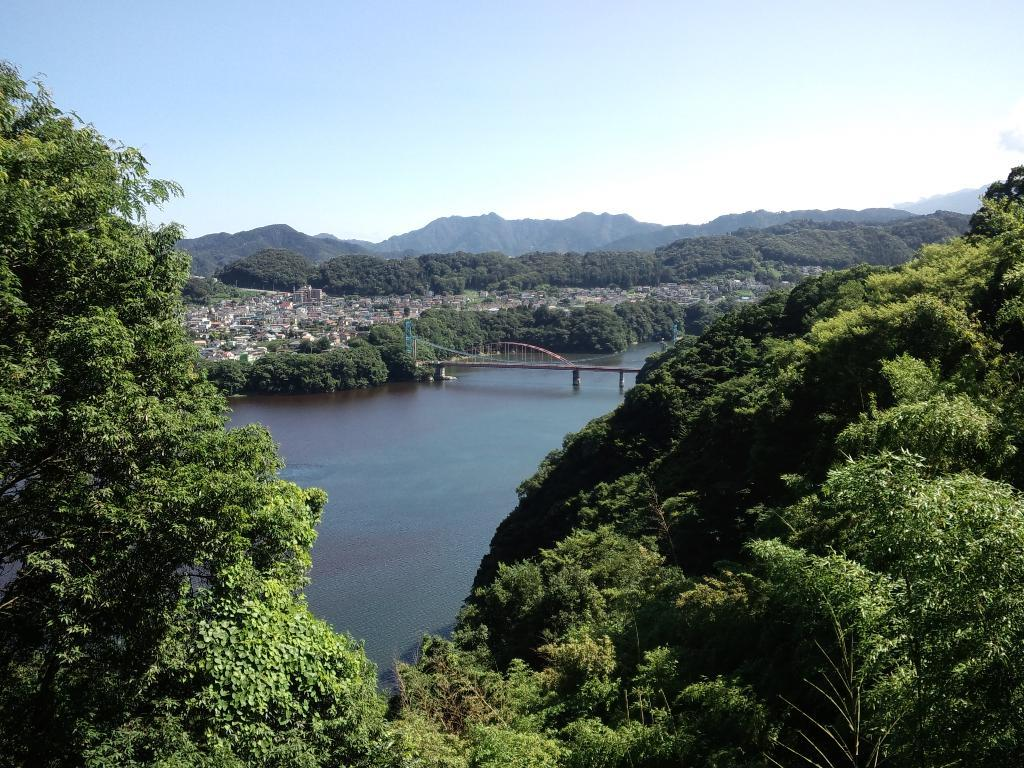What type of natural elements can be seen in the image? There are trees in the image. What man-made structure is present in the image? There is a bridge above the water in the image. What can be seen in the distance beyond the bridge? There are buildings and trees visible in the distance. What type of quiver is present in the image? There is no quiver present in the image. What can be observed about the water in the image? The provided facts do not mention any details about the water in the image, so it cannot be observed or described. 